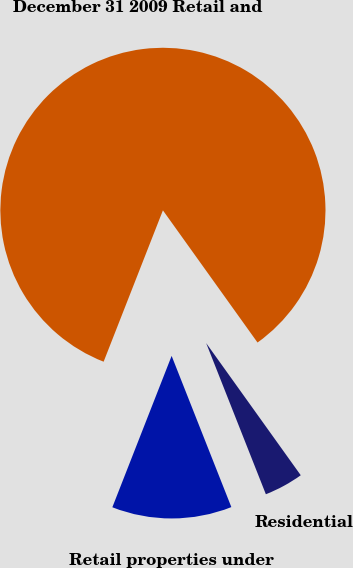Convert chart to OTSL. <chart><loc_0><loc_0><loc_500><loc_500><pie_chart><fcel>December 31 2009 Retail and<fcel>Retail properties under<fcel>Residential<nl><fcel>84.18%<fcel>11.93%<fcel>3.9%<nl></chart> 